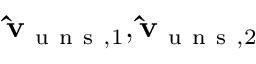Convert formula to latex. <formula><loc_0><loc_0><loc_500><loc_500>\hat { v } _ { u n s , 1 } , \hat { v } _ { u n s , 2 }</formula> 